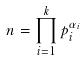<formula> <loc_0><loc_0><loc_500><loc_500>n = \prod _ { i = 1 } ^ { k } p _ { i } ^ { \alpha _ { i } }</formula> 